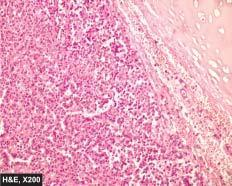what are composed of uniform cuboidal cells having granular cytoplasm?
Answer the question using a single word or phrase. These nests 